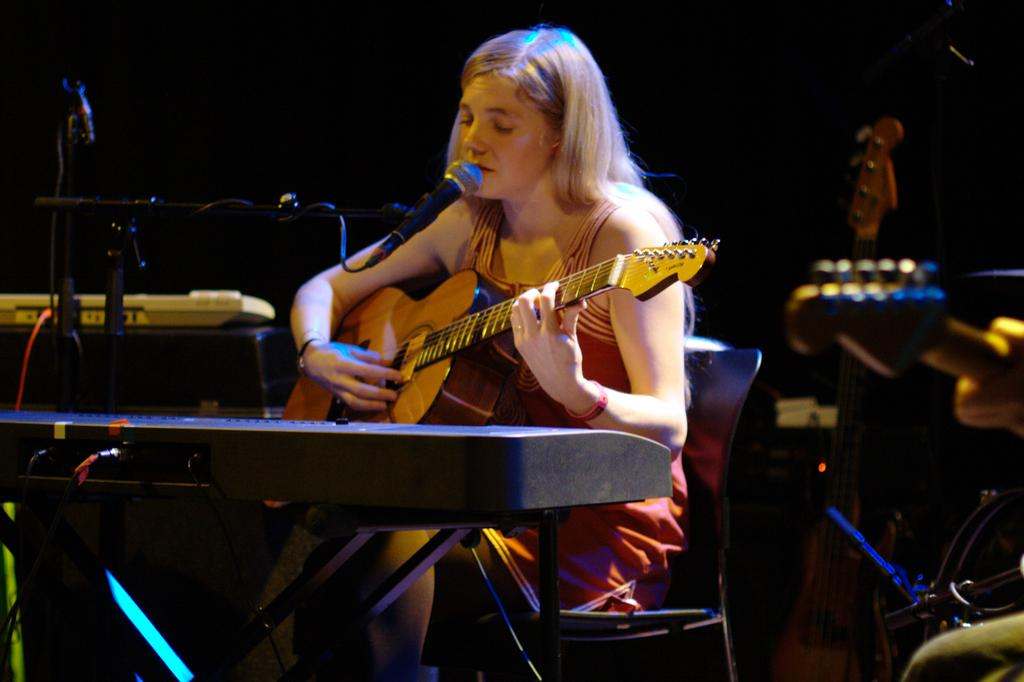Who is the main subject in the image? There is a woman in the image. What is the woman doing in the image? The woman is sitting, playing the guitar, and singing a song. What object is in front of the woman? There is a microphone in front of the woman. What can be seen in the background of the image? There is a stand in the background of the image. What type of tail can be seen on the woman in the image? There is no tail present on the woman in the image. What topic are the woman and her friend discussing in the image? There is no indication of a discussion or a friend in the image; the woman is playing the guitar and singing a song. 